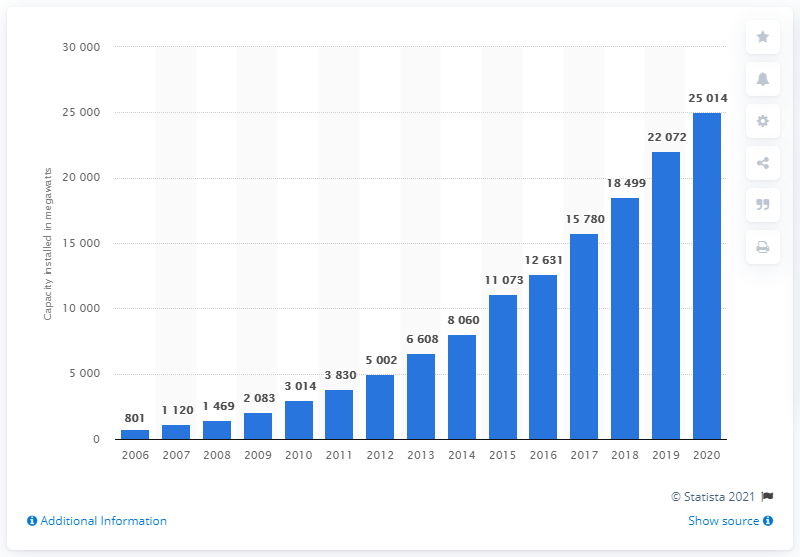Specify some key components in this picture. In 2006, a total of 801 megawatts of installed capacity were reported across all European water bodies. 